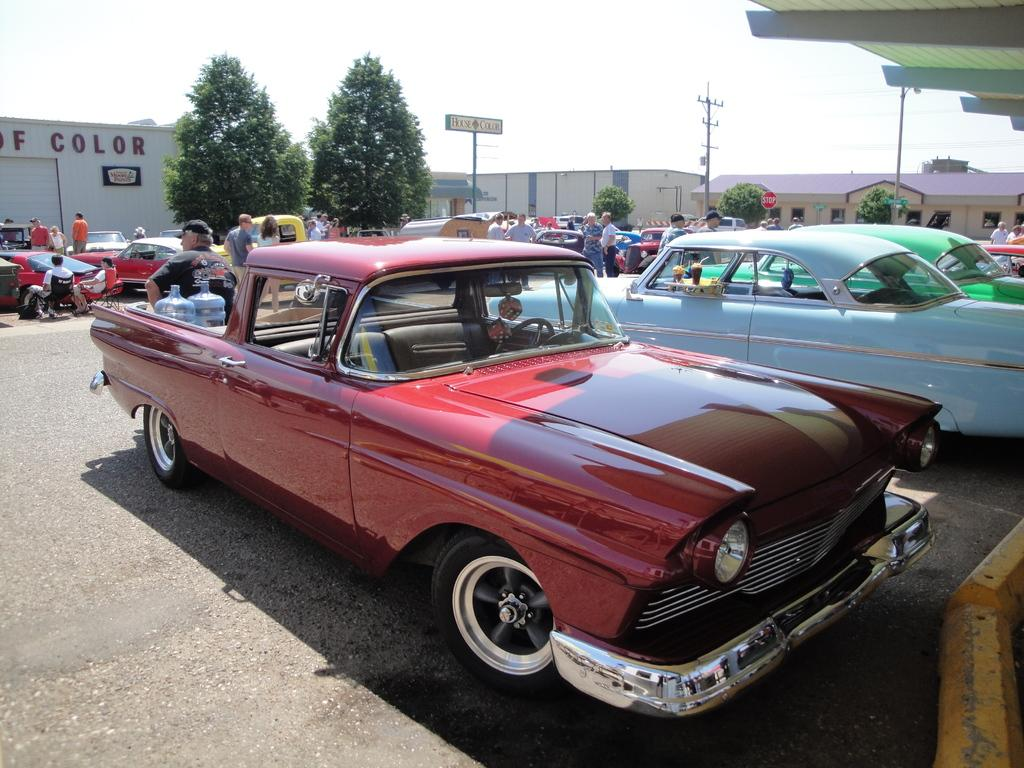What is happening on the road in the image? There are vehicles on the road in the image. What can be seen in the background of the image? There are people, buildings, poles with wires attached, trees, and other unspecified objects in the background of the image. What is visible in the sky in the image? The sky is visible in the background of the image. How many cows are grazing in the bushes in the image? There are no cows or bushes present in the image. 